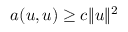Convert formula to latex. <formula><loc_0><loc_0><loc_500><loc_500>a ( u , u ) \geq c \| u \| ^ { 2 }</formula> 